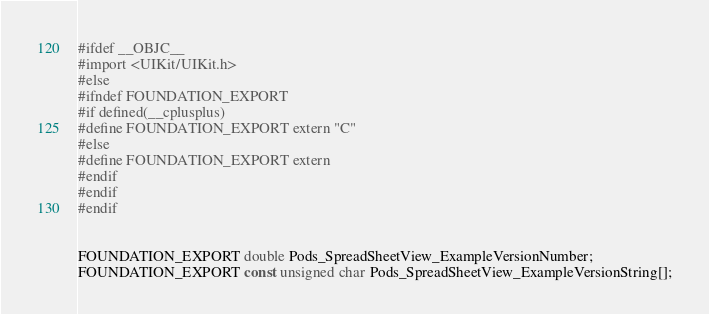<code> <loc_0><loc_0><loc_500><loc_500><_C_>#ifdef __OBJC__
#import <UIKit/UIKit.h>
#else
#ifndef FOUNDATION_EXPORT
#if defined(__cplusplus)
#define FOUNDATION_EXPORT extern "C"
#else
#define FOUNDATION_EXPORT extern
#endif
#endif
#endif


FOUNDATION_EXPORT double Pods_SpreadSheetView_ExampleVersionNumber;
FOUNDATION_EXPORT const unsigned char Pods_SpreadSheetView_ExampleVersionString[];

</code> 